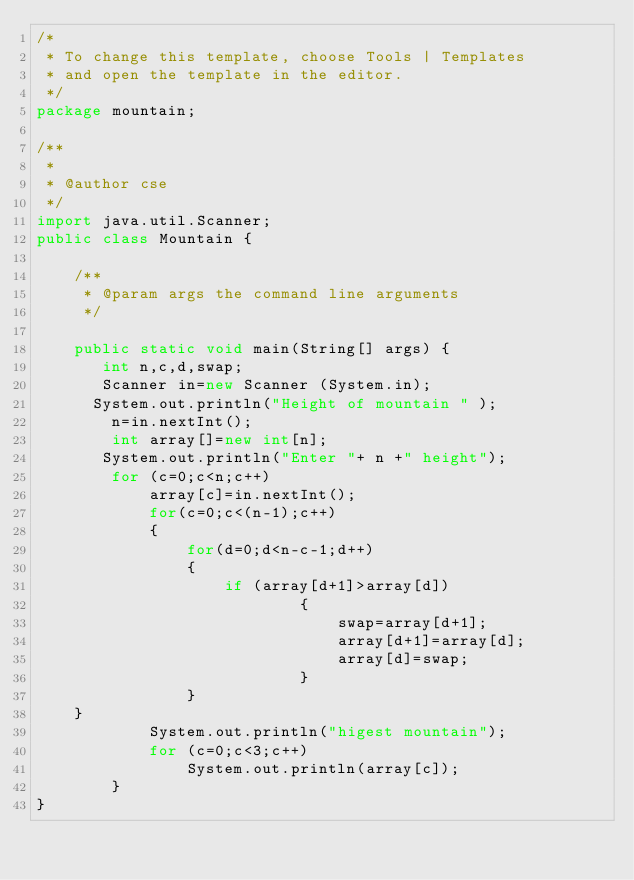<code> <loc_0><loc_0><loc_500><loc_500><_Java_>/*
 * To change this template, choose Tools | Templates
 * and open the template in the editor.
 */
package mountain;

/**
 *
 * @author cse
 */
import java.util.Scanner;
public class Mountain {

    /**
     * @param args the command line arguments
     */
    
    public static void main(String[] args) {
       int n,c,d,swap;
       Scanner in=new Scanner (System.in);
      System.out.println("Height of mountain " );
        n=in.nextInt();
        int array[]=new int[n];
       System.out.println("Enter "+ n +" height");
        for (c=0;c<n;c++)
            array[c]=in.nextInt();
            for(c=0;c<(n-1);c++)
            {
                for(d=0;d<n-c-1;d++)
                {
                    if (array[d+1]>array[d])
                            {
                                swap=array[d+1];
                                array[d+1]=array[d];
                                array[d]=swap;
                            }
                }
    }
            System.out.println("higest mountain");
            for (c=0;c<3;c++)
                System.out.println(array[c]);
        }
}</code> 